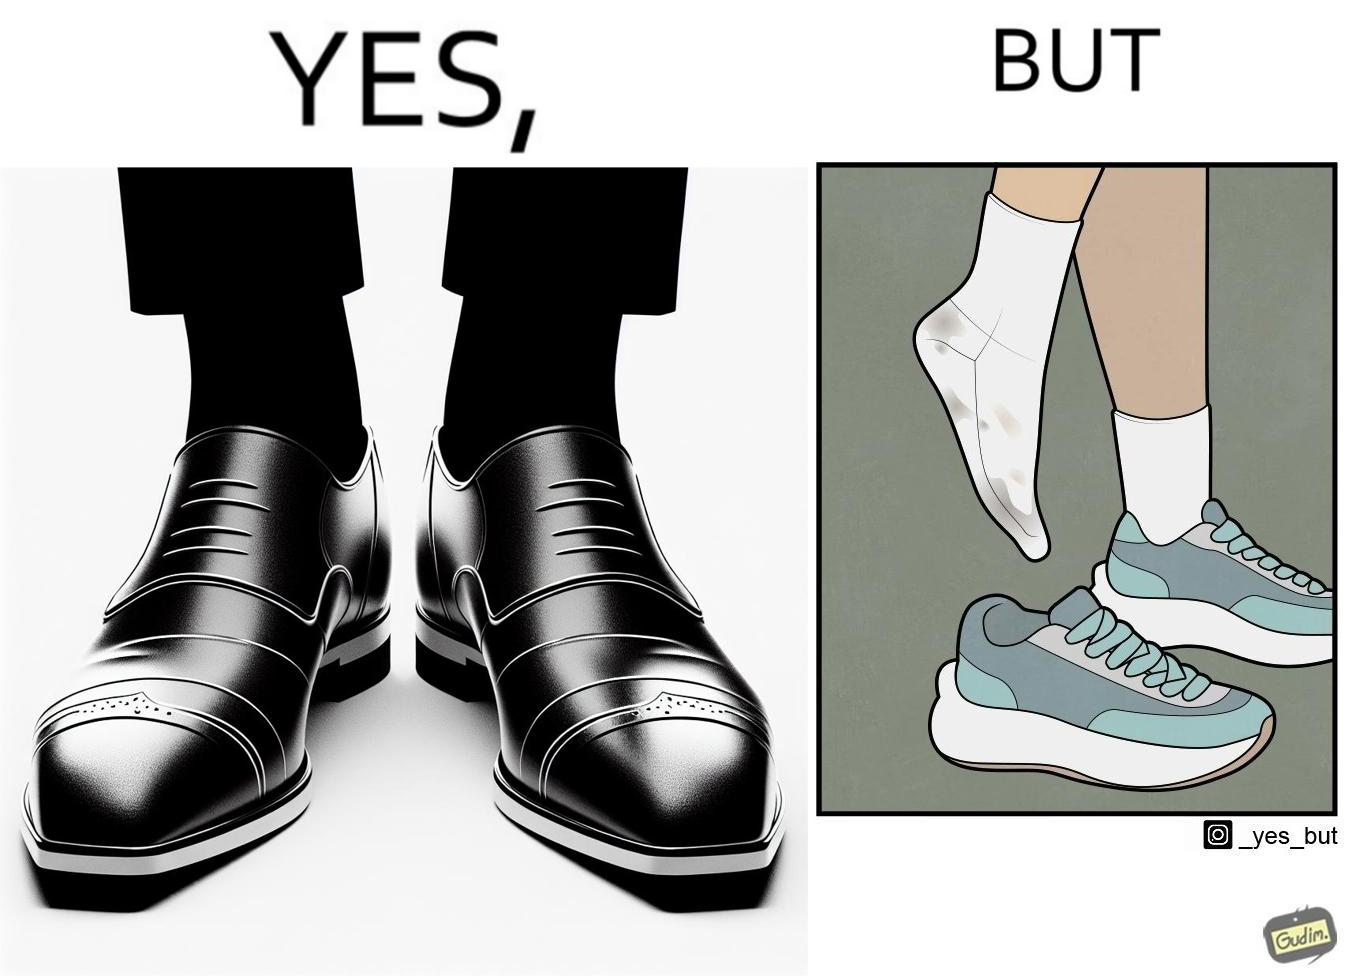Is this a satirical image? Yes, this image is satirical. 